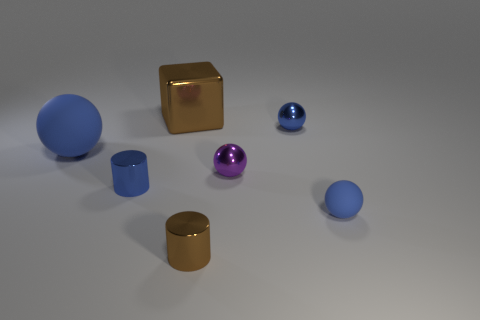What number of brown objects are either small rubber spheres or small things?
Keep it short and to the point. 1. How many shiny things are behind the big matte thing and right of the brown block?
Your answer should be very brief. 1. What material is the blue ball left of the tiny metal cylinder that is in front of the blue rubber sphere on the right side of the cube made of?
Your response must be concise. Rubber. How many large brown objects have the same material as the tiny blue cylinder?
Your response must be concise. 1. There is a small shiny thing that is the same color as the metal block; what is its shape?
Make the answer very short. Cylinder. There is a blue metal object that is the same size as the blue shiny sphere; what is its shape?
Ensure brevity in your answer.  Cylinder. What material is the cylinder that is the same color as the big cube?
Your answer should be compact. Metal. Are there any tiny brown cylinders behind the big matte object?
Your answer should be very brief. No. Are there any other small things that have the same shape as the purple shiny object?
Provide a succinct answer. Yes. Is the shape of the tiny blue thing that is on the left side of the big brown metal block the same as the tiny blue object that is behind the big blue matte object?
Provide a succinct answer. No. 